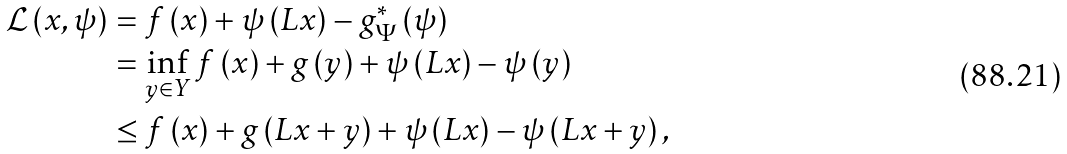Convert formula to latex. <formula><loc_0><loc_0><loc_500><loc_500>\mathcal { L } \left ( x , \psi \right ) & = f \left ( x \right ) + \psi \left ( L x \right ) - g _ { \Psi } ^ { * } \left ( \psi \right ) \\ & = \inf _ { y \in Y } f \left ( x \right ) + g \left ( y \right ) + \psi \left ( L x \right ) - \psi \left ( y \right ) \\ & \leq f \left ( x \right ) + g \left ( L x + y \right ) + \psi \left ( L x \right ) - \psi \left ( L x + y \right ) ,</formula> 